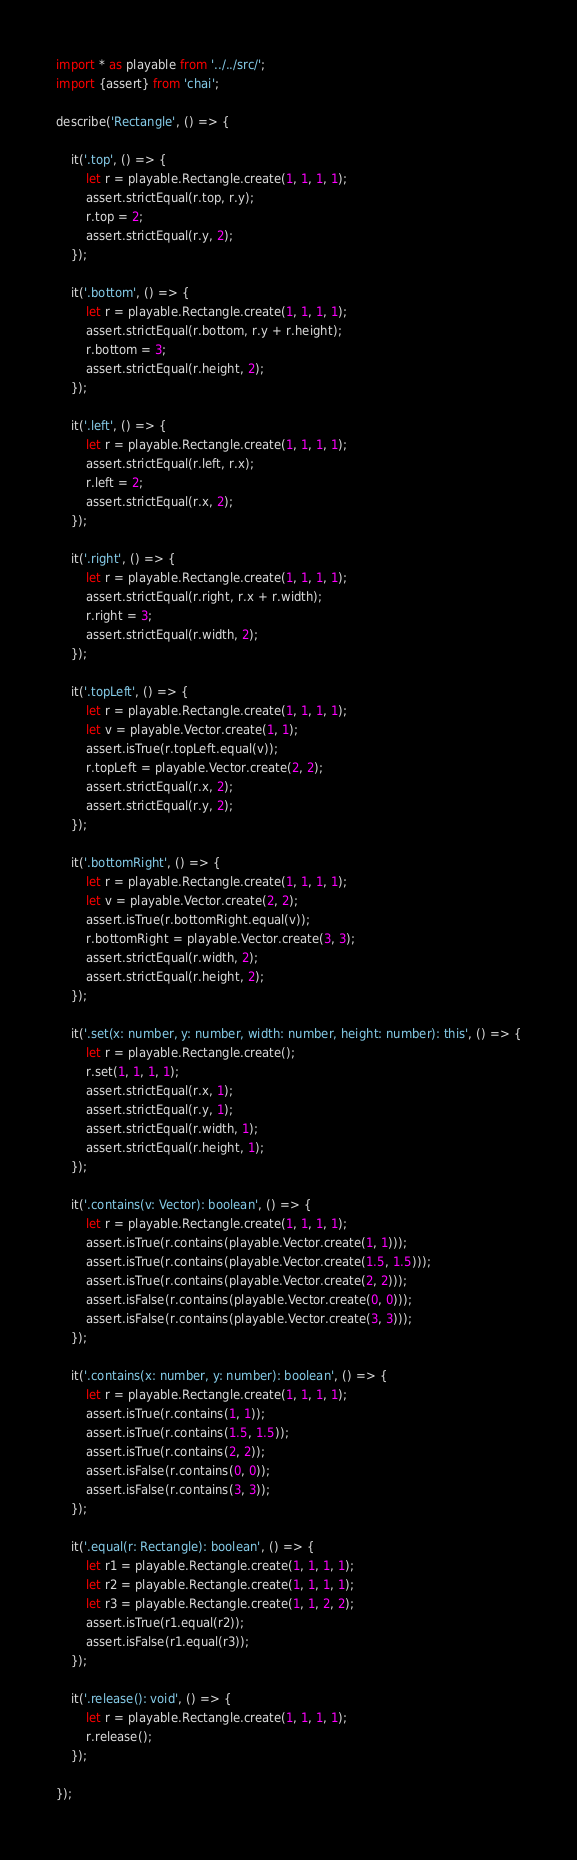Convert code to text. <code><loc_0><loc_0><loc_500><loc_500><_TypeScript_>import * as playable from '../../src/';
import {assert} from 'chai';

describe('Rectangle', () => {

	it('.top', () => {
		let r = playable.Rectangle.create(1, 1, 1, 1);
		assert.strictEqual(r.top, r.y);
		r.top = 2;
		assert.strictEqual(r.y, 2);
	});

	it('.bottom', () => {
		let r = playable.Rectangle.create(1, 1, 1, 1);
		assert.strictEqual(r.bottom, r.y + r.height);
		r.bottom = 3;
		assert.strictEqual(r.height, 2);
	});

	it('.left', () => {
		let r = playable.Rectangle.create(1, 1, 1, 1);
		assert.strictEqual(r.left, r.x);
		r.left = 2;
		assert.strictEqual(r.x, 2);
	});

	it('.right', () => {
		let r = playable.Rectangle.create(1, 1, 1, 1);
		assert.strictEqual(r.right, r.x + r.width);
		r.right = 3;
		assert.strictEqual(r.width, 2);
	});

	it('.topLeft', () => {
		let r = playable.Rectangle.create(1, 1, 1, 1);
		let v = playable.Vector.create(1, 1);
		assert.isTrue(r.topLeft.equal(v));
		r.topLeft = playable.Vector.create(2, 2);
		assert.strictEqual(r.x, 2);
		assert.strictEqual(r.y, 2);
	});

	it('.bottomRight', () => {
		let r = playable.Rectangle.create(1, 1, 1, 1);
		let v = playable.Vector.create(2, 2);
		assert.isTrue(r.bottomRight.equal(v));
		r.bottomRight = playable.Vector.create(3, 3);
		assert.strictEqual(r.width, 2);
		assert.strictEqual(r.height, 2);
	});

	it('.set(x: number, y: number, width: number, height: number): this', () => {
		let r = playable.Rectangle.create();
		r.set(1, 1, 1, 1);
		assert.strictEqual(r.x, 1);
		assert.strictEqual(r.y, 1);
		assert.strictEqual(r.width, 1);
		assert.strictEqual(r.height, 1);
	});

	it('.contains(v: Vector): boolean', () => {
		let r = playable.Rectangle.create(1, 1, 1, 1);
		assert.isTrue(r.contains(playable.Vector.create(1, 1)));
		assert.isTrue(r.contains(playable.Vector.create(1.5, 1.5)));
		assert.isTrue(r.contains(playable.Vector.create(2, 2)));
		assert.isFalse(r.contains(playable.Vector.create(0, 0)));
		assert.isFalse(r.contains(playable.Vector.create(3, 3)));
	});

	it('.contains(x: number, y: number): boolean', () => {
		let r = playable.Rectangle.create(1, 1, 1, 1);
		assert.isTrue(r.contains(1, 1));
		assert.isTrue(r.contains(1.5, 1.5));
		assert.isTrue(r.contains(2, 2));
		assert.isFalse(r.contains(0, 0));
		assert.isFalse(r.contains(3, 3));
	});

	it('.equal(r: Rectangle): boolean', () => {
		let r1 = playable.Rectangle.create(1, 1, 1, 1);
		let r2 = playable.Rectangle.create(1, 1, 1, 1);
		let r3 = playable.Rectangle.create(1, 1, 2, 2);
		assert.isTrue(r1.equal(r2));
		assert.isFalse(r1.equal(r3));
	});

	it('.release(): void', () => {
		let r = playable.Rectangle.create(1, 1, 1, 1);
		r.release();
	});

});
</code> 